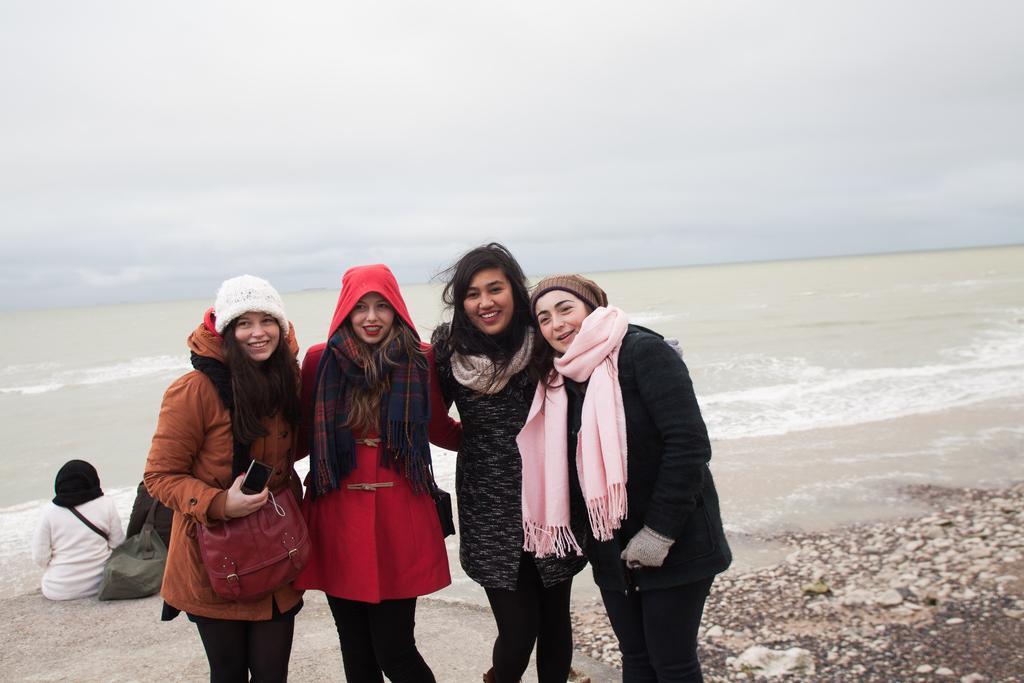In one or two sentences, can you explain what this image depicts? There are women standing and smiling and this woman wore bag and holding a mobile. In the background there are people sitting and we can see bag,water and sky. 